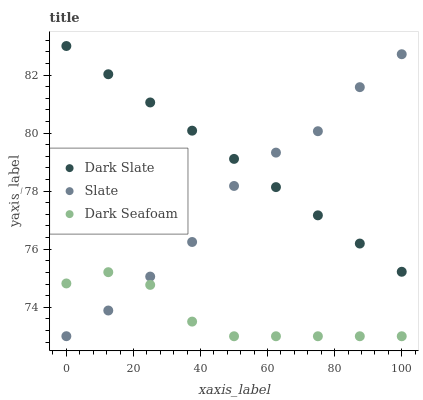Does Dark Seafoam have the minimum area under the curve?
Answer yes or no. Yes. Does Dark Slate have the maximum area under the curve?
Answer yes or no. Yes. Does Slate have the minimum area under the curve?
Answer yes or no. No. Does Slate have the maximum area under the curve?
Answer yes or no. No. Is Dark Slate the smoothest?
Answer yes or no. Yes. Is Slate the roughest?
Answer yes or no. Yes. Is Dark Seafoam the smoothest?
Answer yes or no. No. Is Dark Seafoam the roughest?
Answer yes or no. No. Does Dark Seafoam have the lowest value?
Answer yes or no. Yes. Does Slate have the lowest value?
Answer yes or no. No. Does Dark Slate have the highest value?
Answer yes or no. Yes. Does Slate have the highest value?
Answer yes or no. No. Is Dark Seafoam less than Dark Slate?
Answer yes or no. Yes. Is Dark Slate greater than Dark Seafoam?
Answer yes or no. Yes. Does Dark Seafoam intersect Slate?
Answer yes or no. Yes. Is Dark Seafoam less than Slate?
Answer yes or no. No. Is Dark Seafoam greater than Slate?
Answer yes or no. No. Does Dark Seafoam intersect Dark Slate?
Answer yes or no. No. 